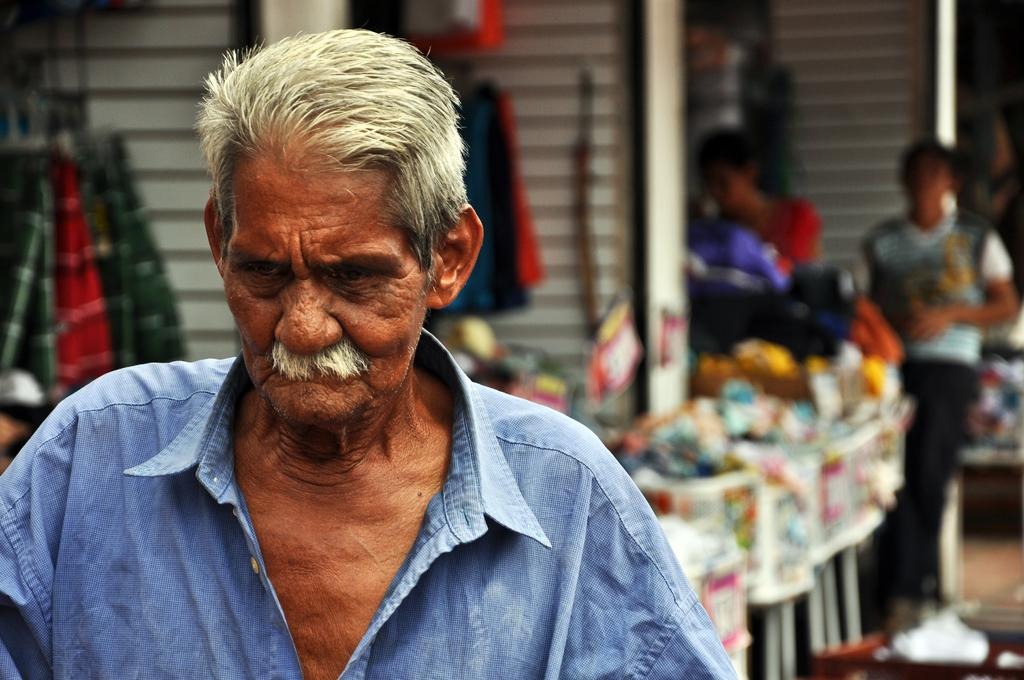What is the person in the image doing? The person is standing in front of a table. What can be seen on the table in the image? There are things placed on the table. Are there any other people visible in the image? Yes, there are other people visible in the image. What reason does the person standing in front of the table give for their approval of the offer? There is no mention of an offer or approval in the image, so it is not possible to answer this question. 